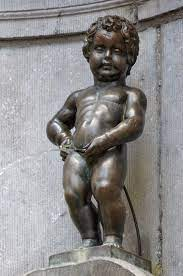Can you tell me more about the history and significance of the Manneken Pis? Certainly! The Manneken Pis, often nicknamed as 'Little Pissing Man' in Dutch, has been a Brussels landmark since the 17th century. Originally installed in 1619, the statue has become an emblem of the city's rebellious and humorous identity. Over time, it has accumulated over 1,000 costumes, each reflecting different aspects of Belgian culture, international events, or diplomatic relations. Its significance extends beyond mere decoration; it symbolizes the joyful and defiant spirit of Brussels through its unassuming yet bold presence. 